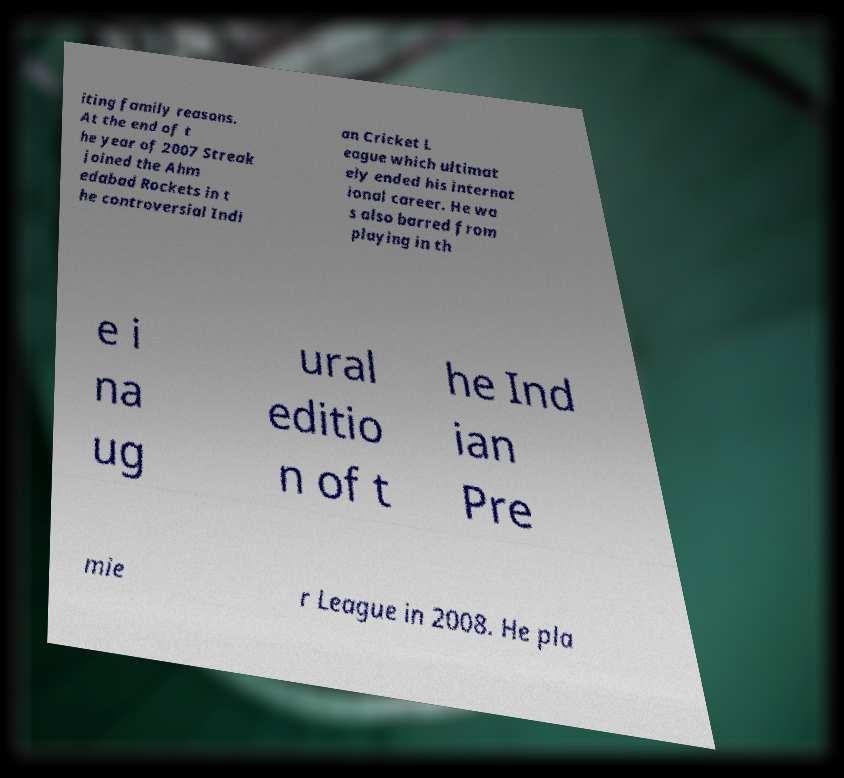Can you read and provide the text displayed in the image?This photo seems to have some interesting text. Can you extract and type it out for me? iting family reasons. At the end of t he year of 2007 Streak joined the Ahm edabad Rockets in t he controversial Indi an Cricket L eague which ultimat ely ended his internat ional career. He wa s also barred from playing in th e i na ug ural editio n of t he Ind ian Pre mie r League in 2008. He pla 